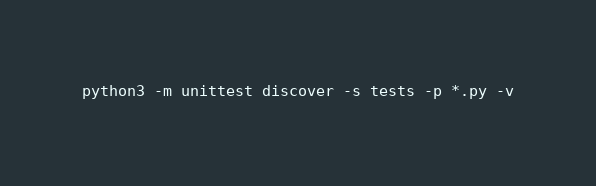Convert code to text. <code><loc_0><loc_0><loc_500><loc_500><_Bash_>python3 -m unittest discover -s tests -p *.py -v
</code> 